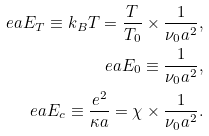<formula> <loc_0><loc_0><loc_500><loc_500>e a E _ { T } \equiv k _ { B } T = \frac { T } { T _ { 0 } } \times \frac { 1 } { \nu _ { 0 } a ^ { 2 } } , \\ \ e a E _ { 0 } \equiv \frac { 1 } { \nu _ { 0 } a ^ { 2 } } , \\ \ e a E _ { c } \equiv \frac { e ^ { 2 } } { \kappa a } = \chi \times \frac { 1 } { \nu _ { 0 } a ^ { 2 } } .</formula> 